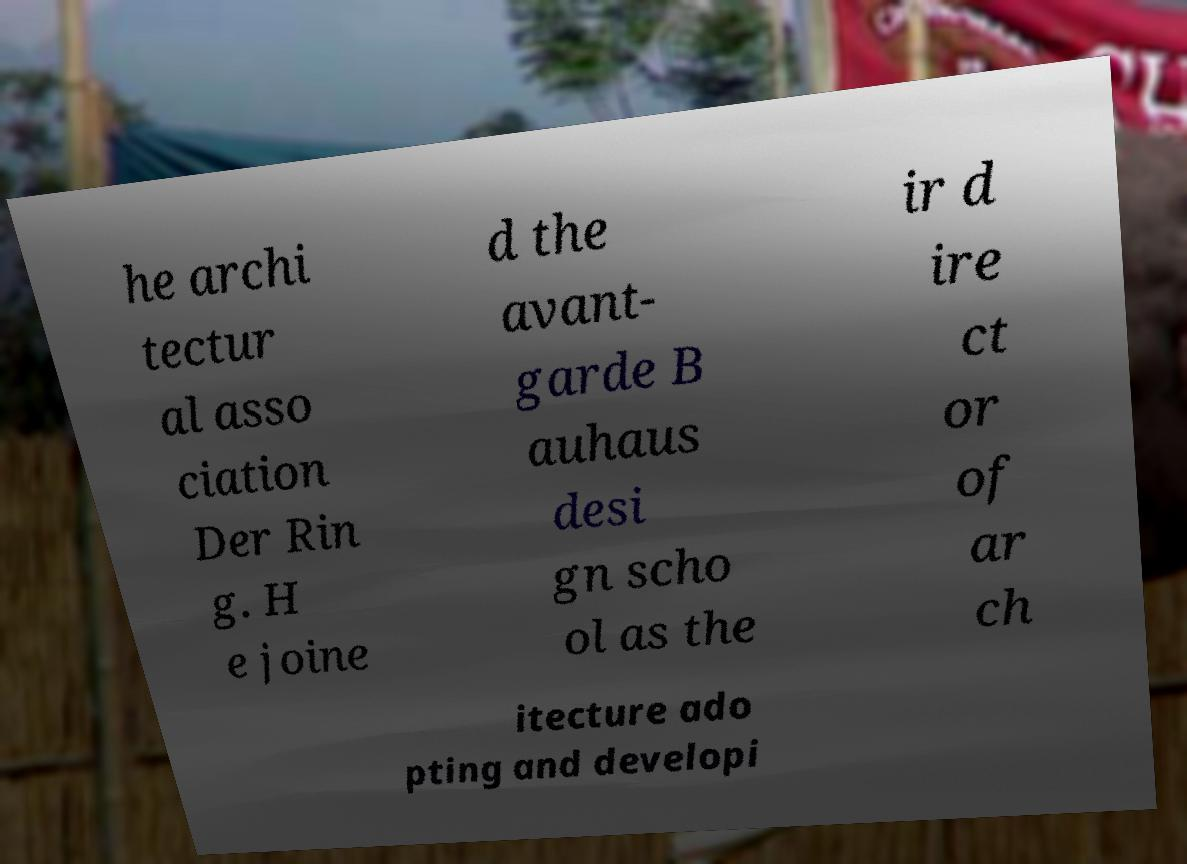Can you read and provide the text displayed in the image?This photo seems to have some interesting text. Can you extract and type it out for me? he archi tectur al asso ciation Der Rin g. H e joine d the avant- garde B auhaus desi gn scho ol as the ir d ire ct or of ar ch itecture ado pting and developi 